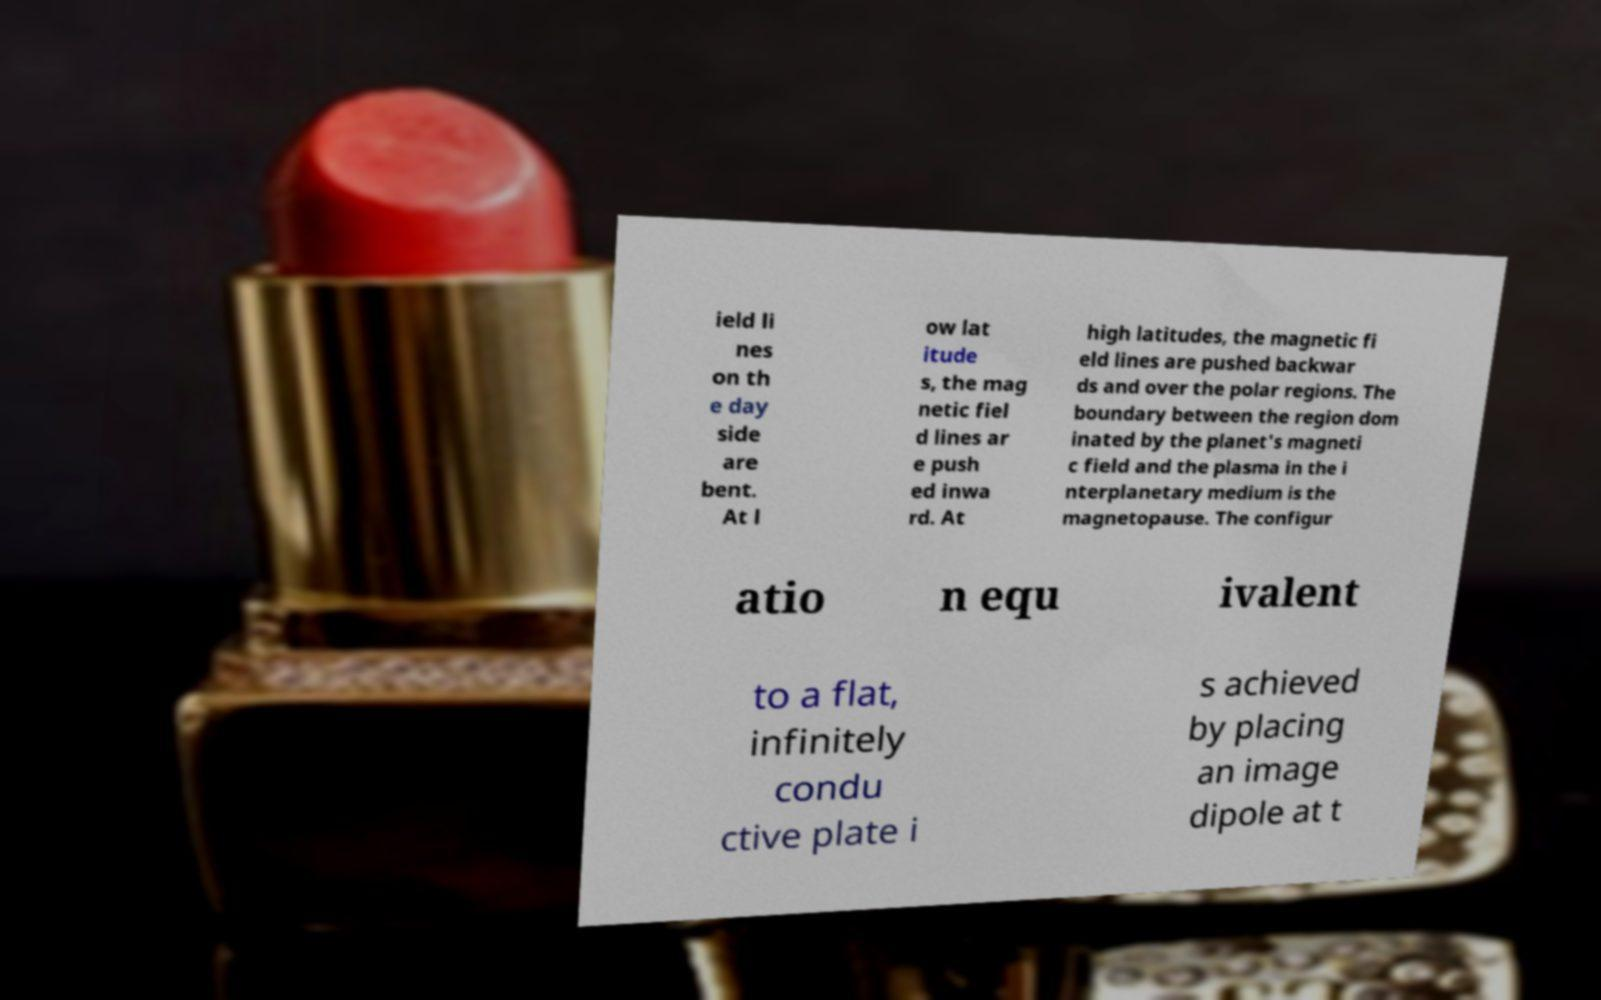Can you read and provide the text displayed in the image?This photo seems to have some interesting text. Can you extract and type it out for me? ield li nes on th e day side are bent. At l ow lat itude s, the mag netic fiel d lines ar e push ed inwa rd. At high latitudes, the magnetic fi eld lines are pushed backwar ds and over the polar regions. The boundary between the region dom inated by the planet's magneti c field and the plasma in the i nterplanetary medium is the magnetopause. The configur atio n equ ivalent to a flat, infinitely condu ctive plate i s achieved by placing an image dipole at t 